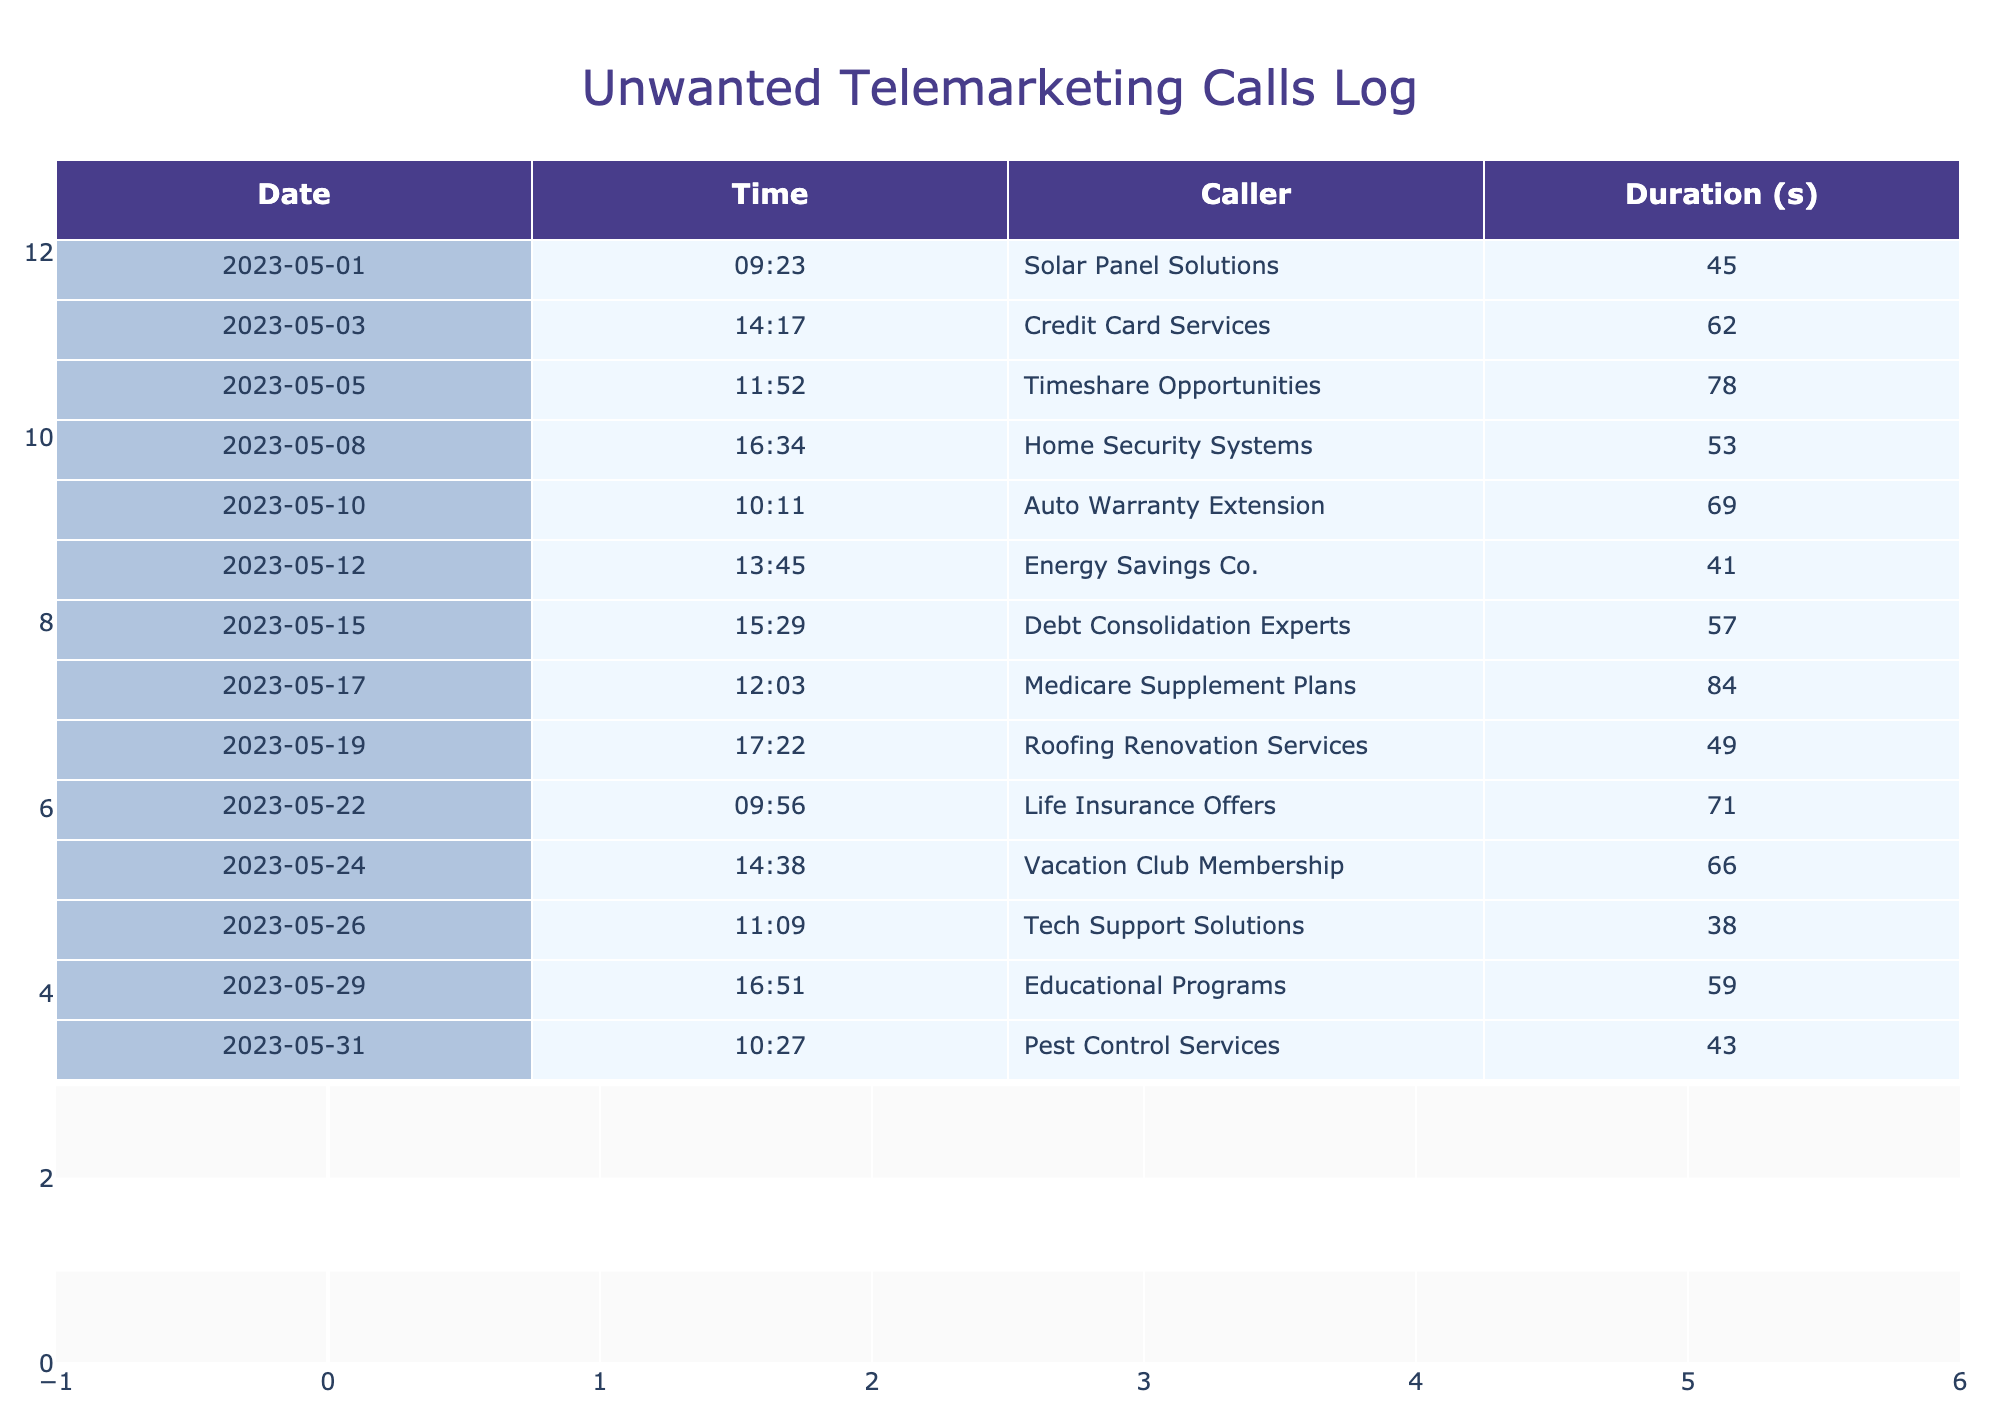What was the duration of the longest call? The longest call duration is found by looking through the "Duration (seconds)" column. Checking the values, the longest duration is 84 seconds from the call on May 17th.
Answer: 84 seconds How many different callers contacted over the month? By counting the unique entries in the "Caller" column, I found that there are 14 different callers listed in the table, suggesting a variety of telemarketing services.
Answer: 14 What is the total duration of all calls combined? To find the total duration of calls, I add up all the durations listed in the "Duration (seconds)" column. The sum is 45 + 62 + 78 + 53 + 69 + 41 + 57 + 84 + 49 + 71 + 66 + 38 + 59 + 43 =  735 seconds. Therefore, the total duration of all calls is 735 seconds.
Answer: 735 seconds Did any caller contact more than once during the month? I checked the "Caller" column to identify any repeating names. The table shows each caller's name only once, indicating that no caller contacted multiple times during the month.
Answer: No What percentage of the calls were longer than 60 seconds? First, I need to see how many calls had a duration greater than 60 seconds. There are 7 such calls: Credit Card Services, Timeshare Opportunities, Auto Warranty Extension, Medicare Supplement Plans, Life Insurance Offers, Vacation Club Membership, and Debt Consolidation Experts. The total number of calls is 14, so the percentage is (7/14) * 100 = 50%.
Answer: 50% Which caller had the shortest duration, and what was it? To identify the shortest duration, I examine the "Duration (seconds)" column for the lowest value. The shortest call is from Tech Support Solutions, which lasted 38 seconds on May 26th.
Answer: Tech Support Solutions, 38 seconds How many calls occurred in the morning (before 12 PM)? I need to filter the "Time" column to identify calls that occurred before 12 PM. The calls on May 1, 3, 8, 10, 12, and 22 occurred during the morning. There are 6 calls in total that were made before noon.
Answer: 6 calls What was the average duration of calls made after May 15? For calls after May 15, I will check the duration of calls on May 17, 19, 22, 24, 26, 29, and 31. Their durations are 84, 49, 71, 66, 38, 59, and 43 seconds respectively. The sum is 410 seconds, and there are 7 calls, which makes the average duration 410/7 ≈ 58.57 seconds.
Answer: Approximately 58.57 seconds 